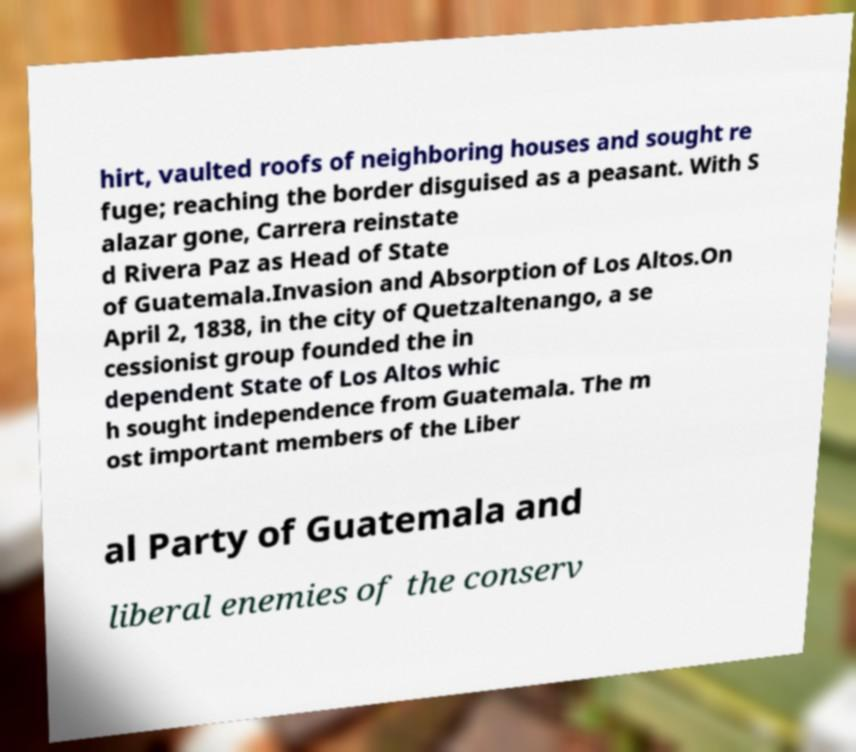There's text embedded in this image that I need extracted. Can you transcribe it verbatim? hirt, vaulted roofs of neighboring houses and sought re fuge; reaching the border disguised as a peasant. With S alazar gone, Carrera reinstate d Rivera Paz as Head of State of Guatemala.Invasion and Absorption of Los Altos.On April 2, 1838, in the city of Quetzaltenango, a se cessionist group founded the in dependent State of Los Altos whic h sought independence from Guatemala. The m ost important members of the Liber al Party of Guatemala and liberal enemies of the conserv 